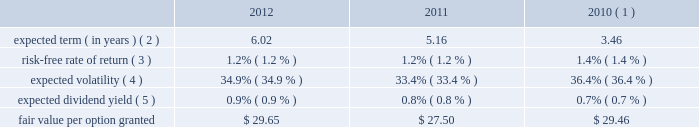Visa inc .
Notes to consolidated financial statements 2014 ( continued ) september 30 , 2012 acquired by the company .
The eip will continue to be in effect until all of the common stock available under the eip is delivered and all restrictions on those shares have lapsed , unless the eip is terminated earlier by the company 2019s board of directors .
No awards may be granted under the plan on or after 10 years from its effective date .
Share-based compensation cost is recorded net of estimated forfeitures on a straight-line basis for awards with service conditions only , and on a graded-vesting basis for awards with service , performance and market conditions .
The company 2019s estimated forfeiture rate is based on an evaluation of historical , actual and trended forfeiture data .
For fiscal 2012 , 2011 , and 2010 , the company recorded share-based compensation cost of $ 147 million , $ 154 million and $ 135 million , respectively , in personnel on its consolidated statements of operations .
The amount of capitalized share-based compensation cost was immaterial during fiscal 2012 , 2011 , and 2010 .
Options options issued under the eip expire 10 years from the date of grant and vest ratably over three years from the date of grant , subject to earlier vesting in full under certain conditions .
During fiscal 2012 , 2011 and 2010 , the fair value of each stock option was estimated on the date of grant using a black-scholes option pricing model with the following weighted-average assumptions : 2012 2011 2010 ( 1 ) expected term ( in years ) ( 2 ) .
6.02 5.16 3.46 risk-free rate of return ( 3 ) .
1.2% ( 1.2 % ) 1.2% ( 1.2 % ) 1.4% ( 1.4 % ) expected volatility ( 4 ) .
34.9% ( 34.9 % ) 33.4% ( 33.4 % ) 36.4% ( 36.4 % ) expected dividend yield ( 5 ) .
0.9% ( 0.9 % ) 0.8% ( 0.8 % ) 0.7% ( 0.7 % ) .
( 1 ) includes the impact of 1.6 million replacement awards issued to former cybersource employees as part of the cybersource acquisition in july 2010 .
These awards have a weighted-average exercise price of $ 47.34 per share and vest over a period of less than three years from the replacement grant date .
( 2 ) based on a set of peer companies that management believes is generally comparable to visa .
( 3 ) based upon the zero coupon u.s .
Treasury bond rate over the expected term of the awards .
( 4 ) based on the average of the company 2019s implied and historical volatility .
As the company 2019s publicly traded stock history is relatively short , historical volatility relies in part on the historical volatility of a group of peer companies that management believes is generally comparable to visa .
The expected volatilities ranged from 31% ( 31 % ) to 35% ( 35 % ) in fiscal 2012 .
( 5 ) based on the company 2019s annual dividend rate on the date of grant. .
What is the total value of the awards issued to former cybersource employee , ( in million ) ? 
Computations: (1.6 * 47.34)
Answer: 75.744. 